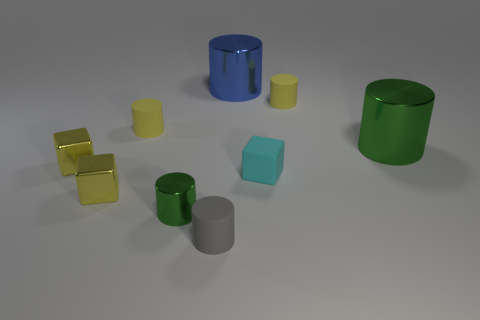Subtract all yellow cubes. How many were subtracted if there are1yellow cubes left? 1 Subtract all blue balls. How many yellow cubes are left? 2 Subtract all cyan rubber cubes. How many cubes are left? 2 Subtract 1 blocks. How many blocks are left? 2 Subtract all yellow cylinders. How many cylinders are left? 4 Add 1 tiny metallic cylinders. How many objects exist? 10 Subtract all yellow cylinders. Subtract all red balls. How many cylinders are left? 4 Subtract all large metallic things. Subtract all tiny yellow things. How many objects are left? 3 Add 3 rubber blocks. How many rubber blocks are left? 4 Add 8 tiny yellow metallic blocks. How many tiny yellow metallic blocks exist? 10 